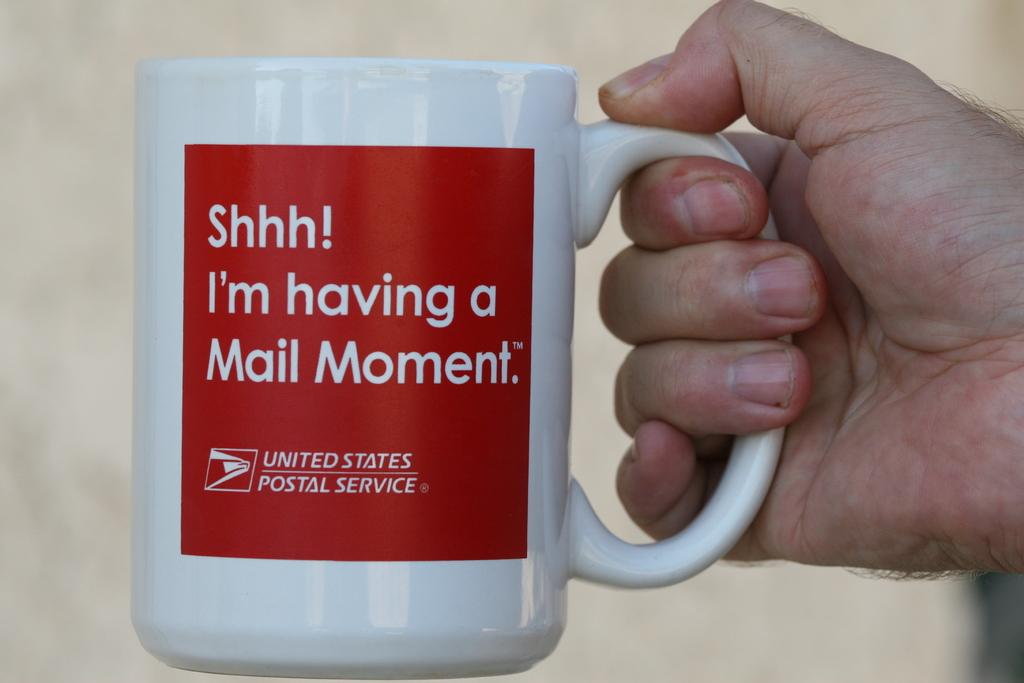Provide a one-sentence caption for the provided image. a united states postal service cup with a cute saying. 